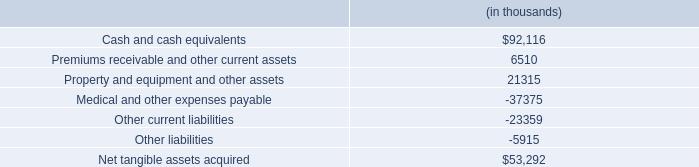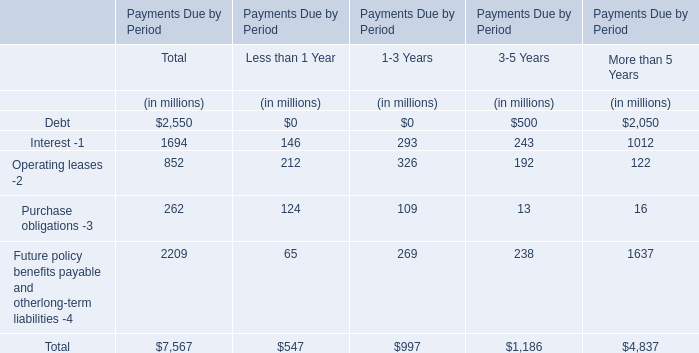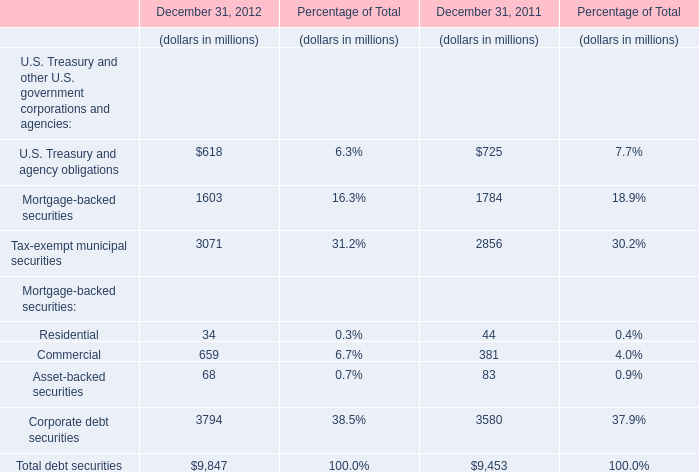what is the total value of liabilities , in thousands? 
Computations: ((37375 + 23359) + 5915)
Answer: 66649.0. 